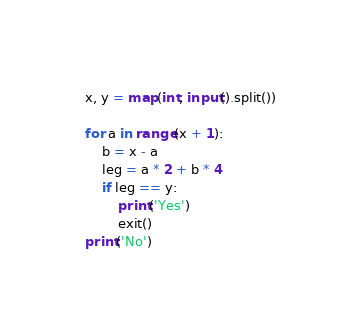Convert code to text. <code><loc_0><loc_0><loc_500><loc_500><_Python_>x, y = map(int, input().split())

for a in range(x + 1):
    b = x - a
    leg = a * 2 + b * 4
    if leg == y:
        print('Yes')
        exit()
print('No')</code> 